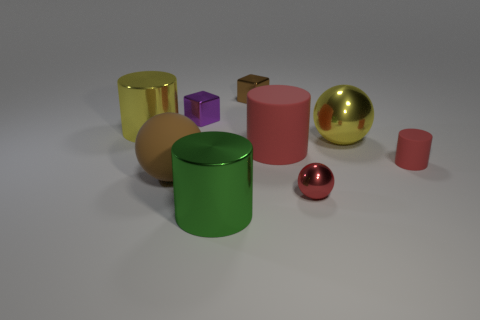How many objects are either shiny objects on the left side of the small red ball or objects?
Offer a terse response. 9. The purple thing that is made of the same material as the tiny brown thing is what size?
Keep it short and to the point. Small. There is a purple block; is its size the same as the cylinder in front of the big brown rubber thing?
Offer a terse response. No. What color is the thing that is both right of the brown matte ball and on the left side of the big green object?
Keep it short and to the point. Purple. What number of objects are large cylinders to the right of the brown metal object or spheres behind the small red metal object?
Offer a terse response. 3. The small object that is right of the small metal object that is in front of the red object that is left of the tiny red shiny thing is what color?
Your answer should be very brief. Red. Are there any brown metallic objects that have the same shape as the small purple thing?
Offer a very short reply. Yes. What number of small red objects are there?
Ensure brevity in your answer.  2. The large green object has what shape?
Your response must be concise. Cylinder. How many green objects are the same size as the brown metal thing?
Keep it short and to the point. 0. 